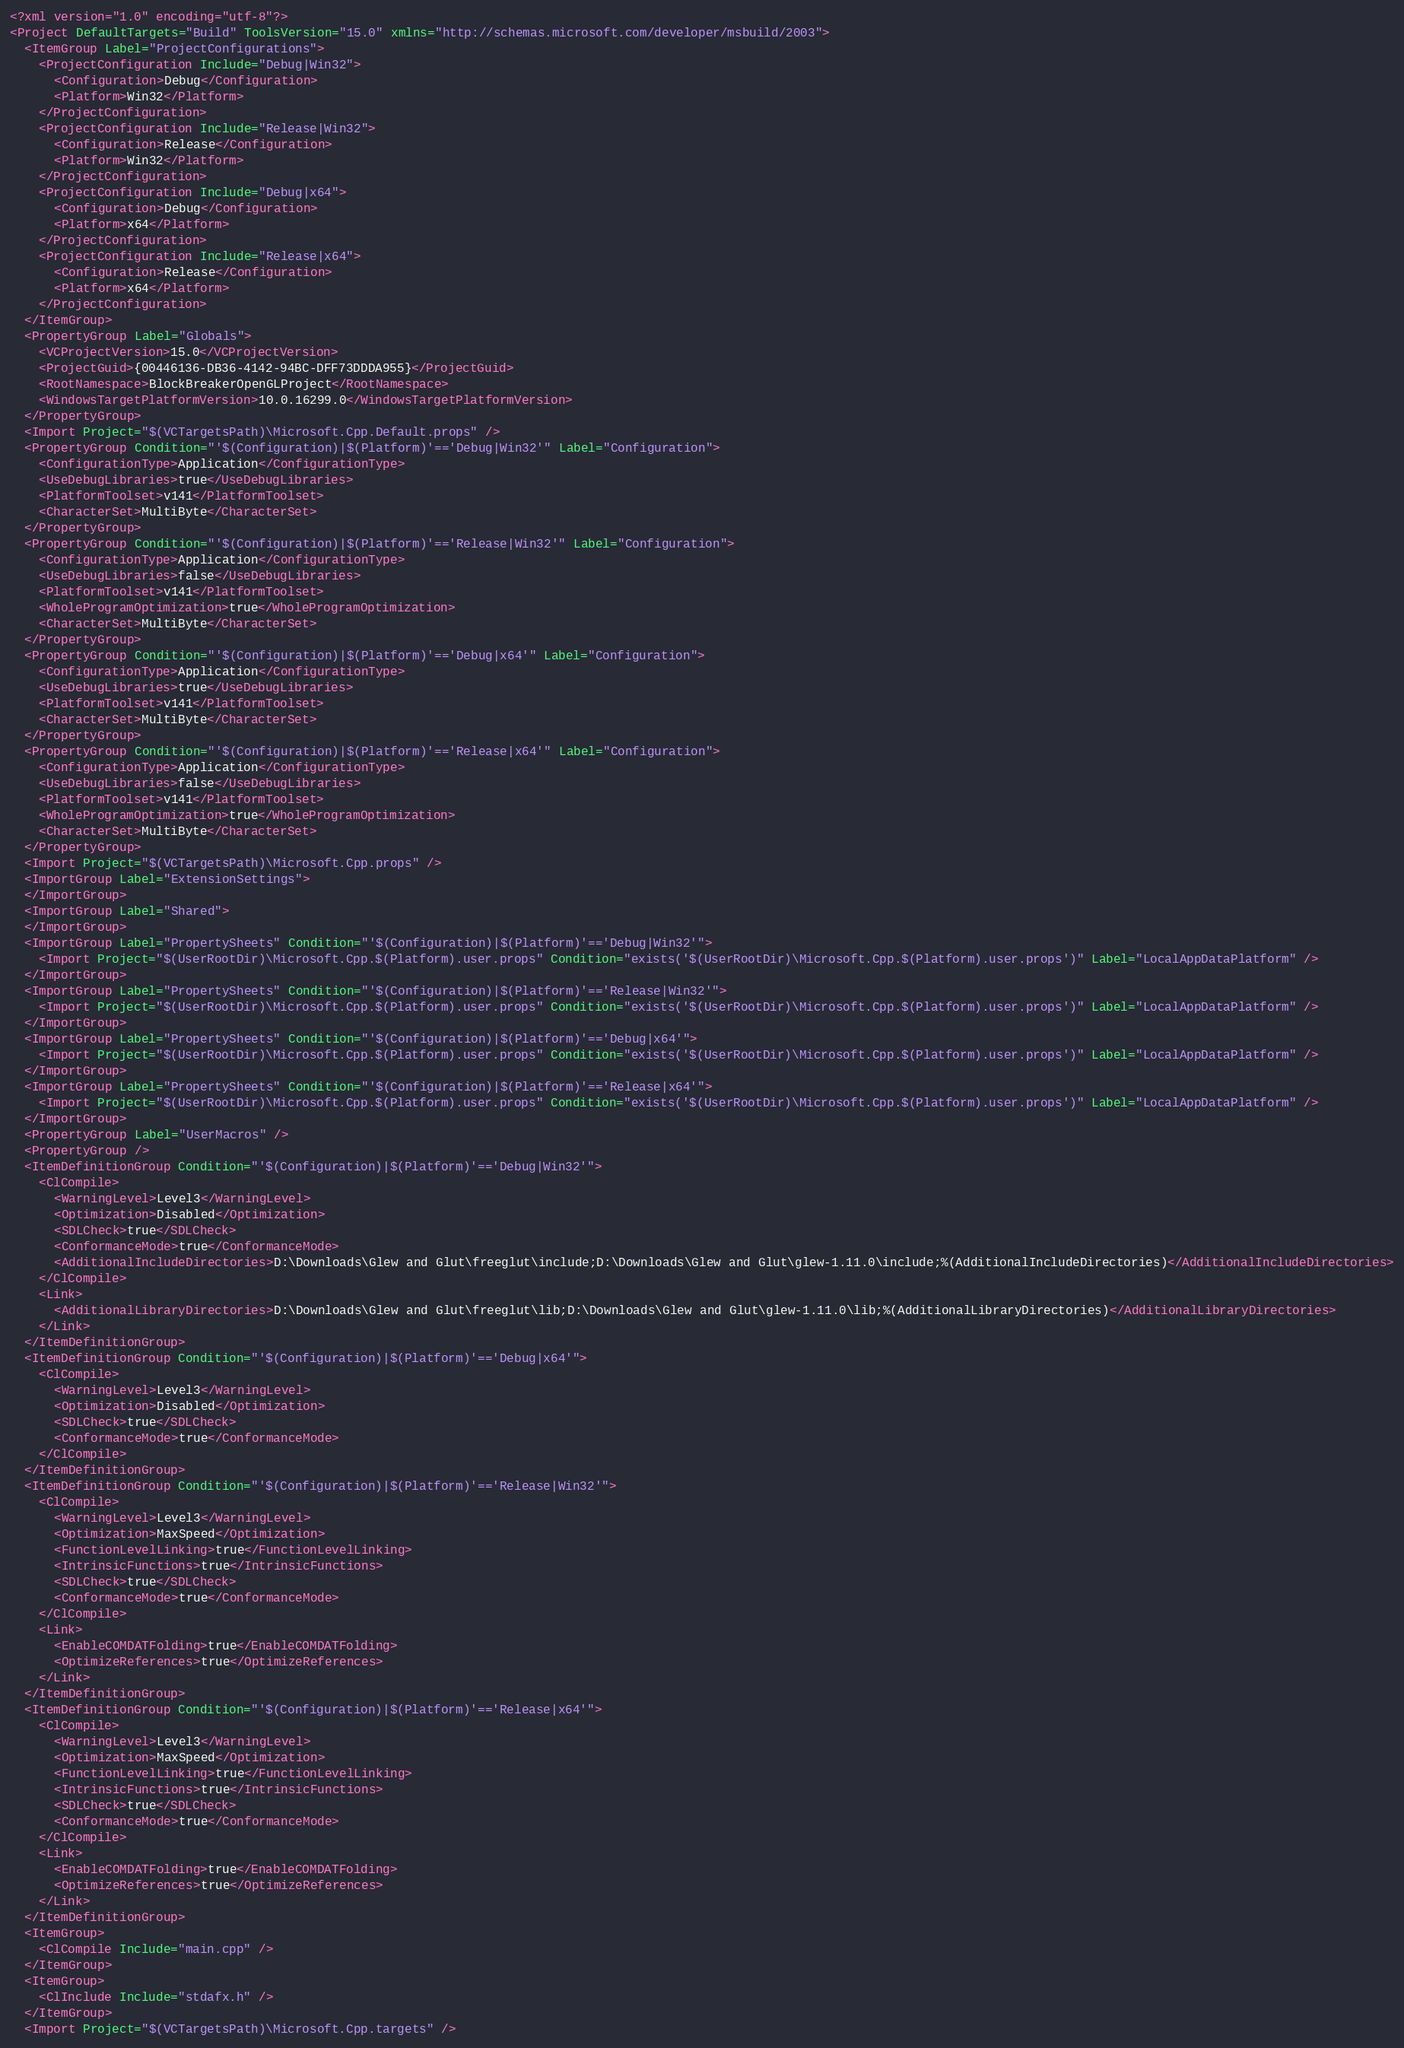Convert code to text. <code><loc_0><loc_0><loc_500><loc_500><_XML_><?xml version="1.0" encoding="utf-8"?>
<Project DefaultTargets="Build" ToolsVersion="15.0" xmlns="http://schemas.microsoft.com/developer/msbuild/2003">
  <ItemGroup Label="ProjectConfigurations">
    <ProjectConfiguration Include="Debug|Win32">
      <Configuration>Debug</Configuration>
      <Platform>Win32</Platform>
    </ProjectConfiguration>
    <ProjectConfiguration Include="Release|Win32">
      <Configuration>Release</Configuration>
      <Platform>Win32</Platform>
    </ProjectConfiguration>
    <ProjectConfiguration Include="Debug|x64">
      <Configuration>Debug</Configuration>
      <Platform>x64</Platform>
    </ProjectConfiguration>
    <ProjectConfiguration Include="Release|x64">
      <Configuration>Release</Configuration>
      <Platform>x64</Platform>
    </ProjectConfiguration>
  </ItemGroup>
  <PropertyGroup Label="Globals">
    <VCProjectVersion>15.0</VCProjectVersion>
    <ProjectGuid>{00446136-DB36-4142-94BC-DFF73DDDA955}</ProjectGuid>
    <RootNamespace>BlockBreakerOpenGLProject</RootNamespace>
    <WindowsTargetPlatformVersion>10.0.16299.0</WindowsTargetPlatformVersion>
  </PropertyGroup>
  <Import Project="$(VCTargetsPath)\Microsoft.Cpp.Default.props" />
  <PropertyGroup Condition="'$(Configuration)|$(Platform)'=='Debug|Win32'" Label="Configuration">
    <ConfigurationType>Application</ConfigurationType>
    <UseDebugLibraries>true</UseDebugLibraries>
    <PlatformToolset>v141</PlatformToolset>
    <CharacterSet>MultiByte</CharacterSet>
  </PropertyGroup>
  <PropertyGroup Condition="'$(Configuration)|$(Platform)'=='Release|Win32'" Label="Configuration">
    <ConfigurationType>Application</ConfigurationType>
    <UseDebugLibraries>false</UseDebugLibraries>
    <PlatformToolset>v141</PlatformToolset>
    <WholeProgramOptimization>true</WholeProgramOptimization>
    <CharacterSet>MultiByte</CharacterSet>
  </PropertyGroup>
  <PropertyGroup Condition="'$(Configuration)|$(Platform)'=='Debug|x64'" Label="Configuration">
    <ConfigurationType>Application</ConfigurationType>
    <UseDebugLibraries>true</UseDebugLibraries>
    <PlatformToolset>v141</PlatformToolset>
    <CharacterSet>MultiByte</CharacterSet>
  </PropertyGroup>
  <PropertyGroup Condition="'$(Configuration)|$(Platform)'=='Release|x64'" Label="Configuration">
    <ConfigurationType>Application</ConfigurationType>
    <UseDebugLibraries>false</UseDebugLibraries>
    <PlatformToolset>v141</PlatformToolset>
    <WholeProgramOptimization>true</WholeProgramOptimization>
    <CharacterSet>MultiByte</CharacterSet>
  </PropertyGroup>
  <Import Project="$(VCTargetsPath)\Microsoft.Cpp.props" />
  <ImportGroup Label="ExtensionSettings">
  </ImportGroup>
  <ImportGroup Label="Shared">
  </ImportGroup>
  <ImportGroup Label="PropertySheets" Condition="'$(Configuration)|$(Platform)'=='Debug|Win32'">
    <Import Project="$(UserRootDir)\Microsoft.Cpp.$(Platform).user.props" Condition="exists('$(UserRootDir)\Microsoft.Cpp.$(Platform).user.props')" Label="LocalAppDataPlatform" />
  </ImportGroup>
  <ImportGroup Label="PropertySheets" Condition="'$(Configuration)|$(Platform)'=='Release|Win32'">
    <Import Project="$(UserRootDir)\Microsoft.Cpp.$(Platform).user.props" Condition="exists('$(UserRootDir)\Microsoft.Cpp.$(Platform).user.props')" Label="LocalAppDataPlatform" />
  </ImportGroup>
  <ImportGroup Label="PropertySheets" Condition="'$(Configuration)|$(Platform)'=='Debug|x64'">
    <Import Project="$(UserRootDir)\Microsoft.Cpp.$(Platform).user.props" Condition="exists('$(UserRootDir)\Microsoft.Cpp.$(Platform).user.props')" Label="LocalAppDataPlatform" />
  </ImportGroup>
  <ImportGroup Label="PropertySheets" Condition="'$(Configuration)|$(Platform)'=='Release|x64'">
    <Import Project="$(UserRootDir)\Microsoft.Cpp.$(Platform).user.props" Condition="exists('$(UserRootDir)\Microsoft.Cpp.$(Platform).user.props')" Label="LocalAppDataPlatform" />
  </ImportGroup>
  <PropertyGroup Label="UserMacros" />
  <PropertyGroup />
  <ItemDefinitionGroup Condition="'$(Configuration)|$(Platform)'=='Debug|Win32'">
    <ClCompile>
      <WarningLevel>Level3</WarningLevel>
      <Optimization>Disabled</Optimization>
      <SDLCheck>true</SDLCheck>
      <ConformanceMode>true</ConformanceMode>
      <AdditionalIncludeDirectories>D:\Downloads\Glew and Glut\freeglut\include;D:\Downloads\Glew and Glut\glew-1.11.0\include;%(AdditionalIncludeDirectories)</AdditionalIncludeDirectories>
    </ClCompile>
    <Link>
      <AdditionalLibraryDirectories>D:\Downloads\Glew and Glut\freeglut\lib;D:\Downloads\Glew and Glut\glew-1.11.0\lib;%(AdditionalLibraryDirectories)</AdditionalLibraryDirectories>
    </Link>
  </ItemDefinitionGroup>
  <ItemDefinitionGroup Condition="'$(Configuration)|$(Platform)'=='Debug|x64'">
    <ClCompile>
      <WarningLevel>Level3</WarningLevel>
      <Optimization>Disabled</Optimization>
      <SDLCheck>true</SDLCheck>
      <ConformanceMode>true</ConformanceMode>
    </ClCompile>
  </ItemDefinitionGroup>
  <ItemDefinitionGroup Condition="'$(Configuration)|$(Platform)'=='Release|Win32'">
    <ClCompile>
      <WarningLevel>Level3</WarningLevel>
      <Optimization>MaxSpeed</Optimization>
      <FunctionLevelLinking>true</FunctionLevelLinking>
      <IntrinsicFunctions>true</IntrinsicFunctions>
      <SDLCheck>true</SDLCheck>
      <ConformanceMode>true</ConformanceMode>
    </ClCompile>
    <Link>
      <EnableCOMDATFolding>true</EnableCOMDATFolding>
      <OptimizeReferences>true</OptimizeReferences>
    </Link>
  </ItemDefinitionGroup>
  <ItemDefinitionGroup Condition="'$(Configuration)|$(Platform)'=='Release|x64'">
    <ClCompile>
      <WarningLevel>Level3</WarningLevel>
      <Optimization>MaxSpeed</Optimization>
      <FunctionLevelLinking>true</FunctionLevelLinking>
      <IntrinsicFunctions>true</IntrinsicFunctions>
      <SDLCheck>true</SDLCheck>
      <ConformanceMode>true</ConformanceMode>
    </ClCompile>
    <Link>
      <EnableCOMDATFolding>true</EnableCOMDATFolding>
      <OptimizeReferences>true</OptimizeReferences>
    </Link>
  </ItemDefinitionGroup>
  <ItemGroup>
    <ClCompile Include="main.cpp" />
  </ItemGroup>
  <ItemGroup>
    <ClInclude Include="stdafx.h" />
  </ItemGroup>
  <Import Project="$(VCTargetsPath)\Microsoft.Cpp.targets" /></code> 